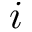<formula> <loc_0><loc_0><loc_500><loc_500>i</formula> 